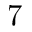<formula> <loc_0><loc_0><loc_500><loc_500>7</formula> 